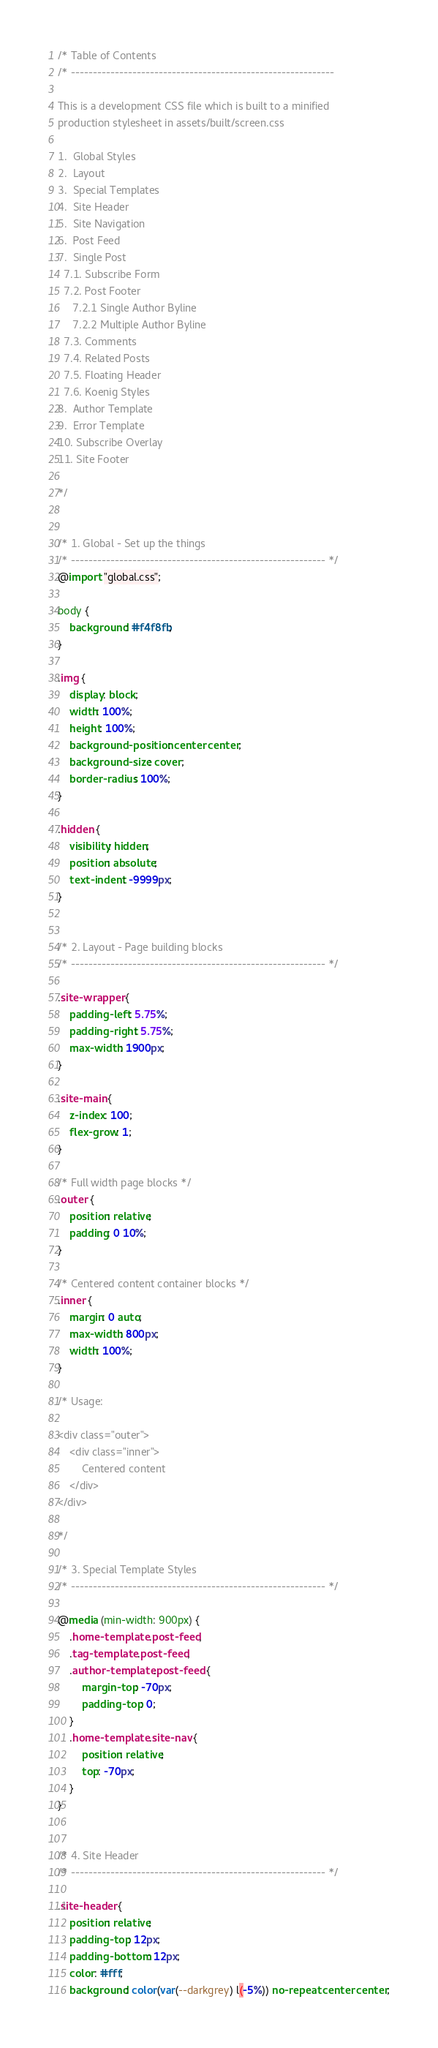<code> <loc_0><loc_0><loc_500><loc_500><_CSS_>/* Table of Contents
/* ------------------------------------------------------------

This is a development CSS file which is built to a minified
production stylesheet in assets/built/screen.css

1.  Global Styles
2.  Layout
3.  Special Templates
4.  Site Header
5.  Site Navigation
6.  Post Feed
7.  Single Post
  7.1. Subscribe Form
  7.2. Post Footer
     7.2.1 Single Author Byline
     7.2.2 Multiple Author Byline
  7.3. Comments
  7.4. Related Posts
  7.5. Floating Header
  7.6. Koenig Styles
8.  Author Template
9.  Error Template
10. Subscribe Overlay
11. Site Footer

*/


/* 1. Global - Set up the things
/* ---------------------------------------------------------- */
@import "global.css";

body {
    background: #f4f8fb;
}

.img {
    display: block;
    width: 100%;
    height: 100%;
    background-position: center center;
    background-size: cover;
    border-radius: 100%;
}

.hidden {
    visibility: hidden;
    position: absolute;
    text-indent: -9999px;
}


/* 2. Layout - Page building blocks
/* ---------------------------------------------------------- */

.site-wrapper {
	padding-left: 5.75%;
	padding-right: 5.75%;
	max-width: 1900px;
}

.site-main {
    z-index: 100;
    flex-grow: 1;
}

/* Full width page blocks */
.outer {
    position: relative;
    padding: 0 10%;
}

/* Centered content container blocks */
.inner {
    margin: 0 auto;
    max-width: 800px;
    width: 100%;
}

/* Usage:

<div class="outer">
    <div class="inner">
        Centered content
    </div>
</div>

*/

/* 3. Special Template Styles
/* ---------------------------------------------------------- */

@media (min-width: 900px) {
    .home-template .post-feed,
    .tag-template .post-feed,
    .author-template .post-feed {
        margin-top: -70px;
        padding-top: 0;
    }
    .home-template .site-nav {
        position: relative;
        top: -70px;
    }
}


/* 4. Site Header
/* ---------------------------------------------------------- */

.site-header {
    position: relative;
    padding-top: 12px;
    padding-bottom: 12px;
    color: #fff;
    background: color(var(--darkgrey) l(-5%)) no-repeat center center;</code> 